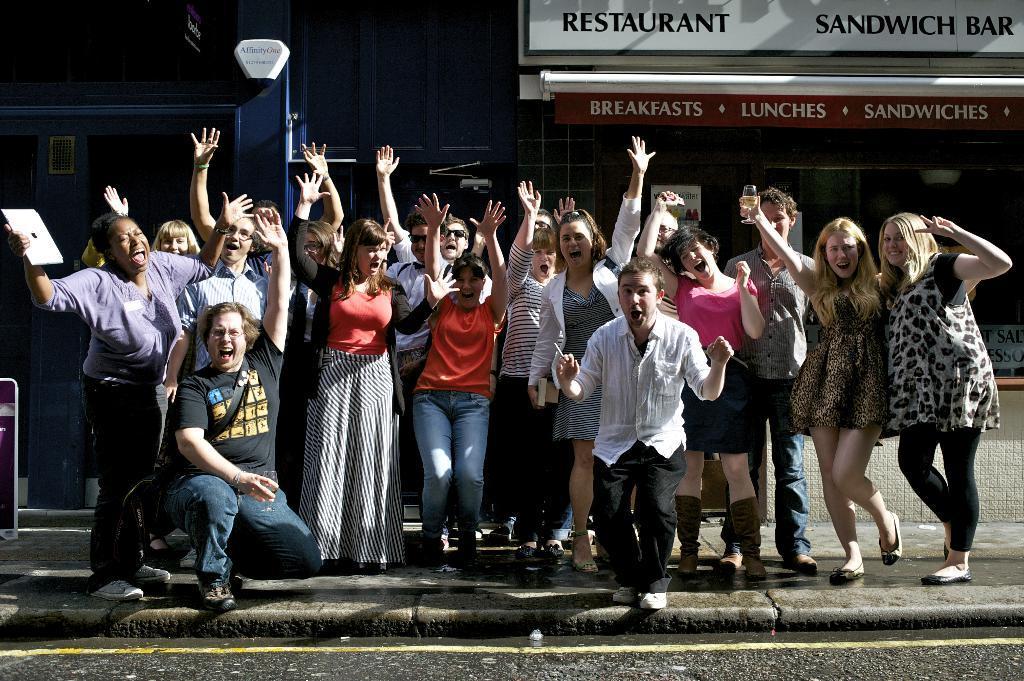Please provide a concise description of this image. There are persons in different color dresses, laughing on a platform. Beside this platform, there is a road, on which there is a yellow color line. In the background, there is a hoarding attached to a wall of a building and a sign board attached to the wall. 